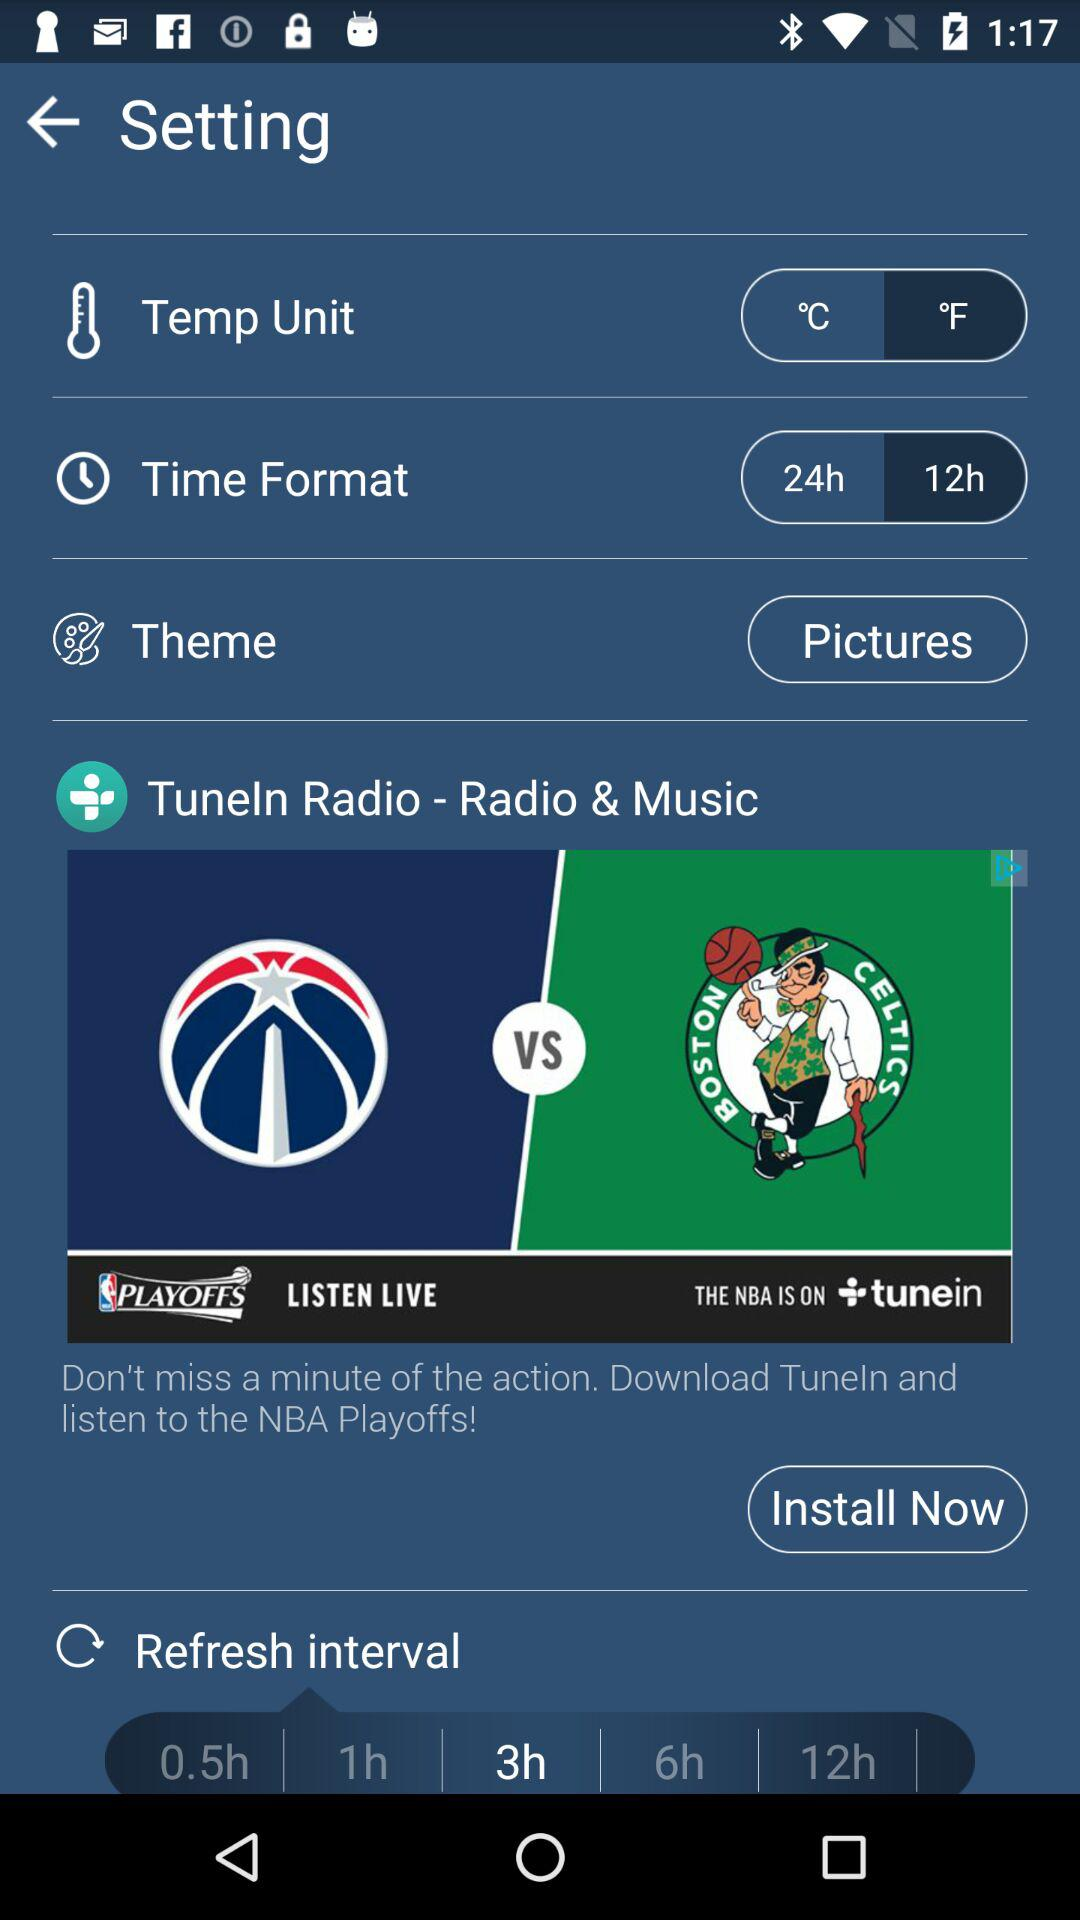Which time format is selected? The selected time format is "12h". 